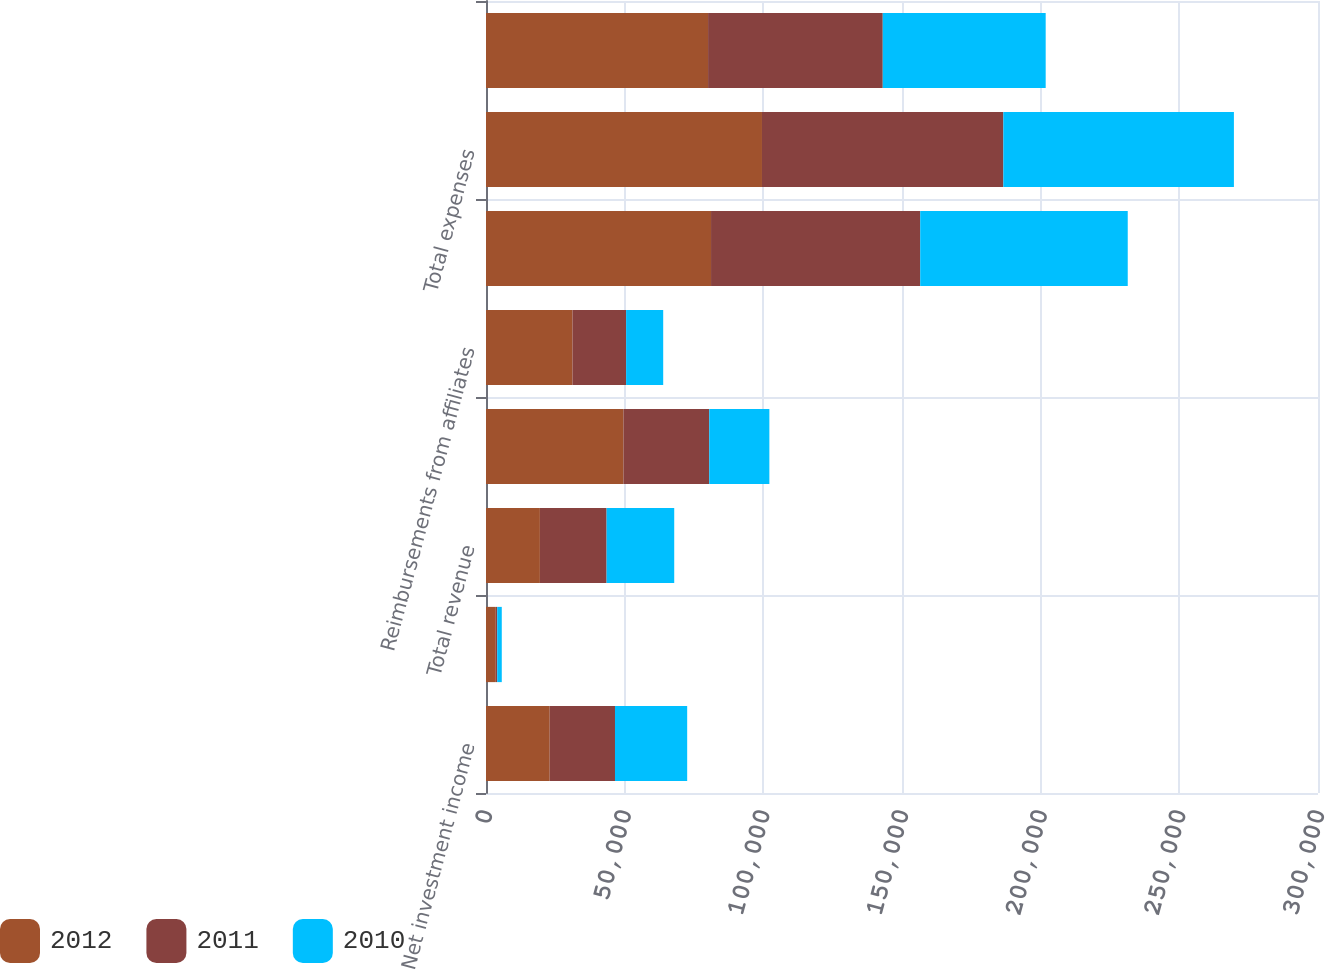Convert chart. <chart><loc_0><loc_0><loc_500><loc_500><stacked_bar_chart><ecel><fcel>Net investment income<fcel>Realized investment gains<fcel>Total revenue<fcel>General operating expenses<fcel>Reimbursements from affiliates<fcel>Interest expense<fcel>Total expenses<fcel>Operating income (loss) before<nl><fcel>2012<fcel>22968<fcel>3534<fcel>19434<fcel>49549<fcel>31184<fcel>81145<fcel>99510<fcel>80076<nl><fcel>2011<fcel>23542<fcel>508<fcel>24050<fcel>30945<fcel>19335<fcel>75426<fcel>87036<fcel>62986<nl><fcel>2010<fcel>26031<fcel>1646<fcel>24385<fcel>21682<fcel>13375<fcel>74827<fcel>83134<fcel>58749<nl></chart> 